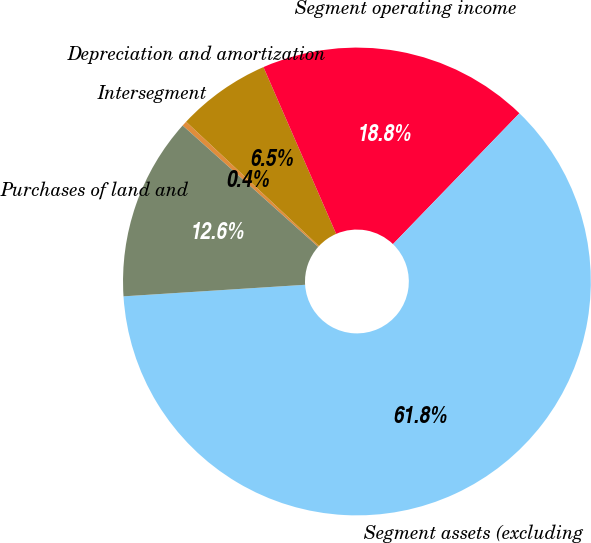<chart> <loc_0><loc_0><loc_500><loc_500><pie_chart><fcel>Intersegment<fcel>Depreciation and amortization<fcel>Segment operating income<fcel>Segment assets (excluding<fcel>Purchases of land and<nl><fcel>0.35%<fcel>6.49%<fcel>18.77%<fcel>61.76%<fcel>12.63%<nl></chart> 